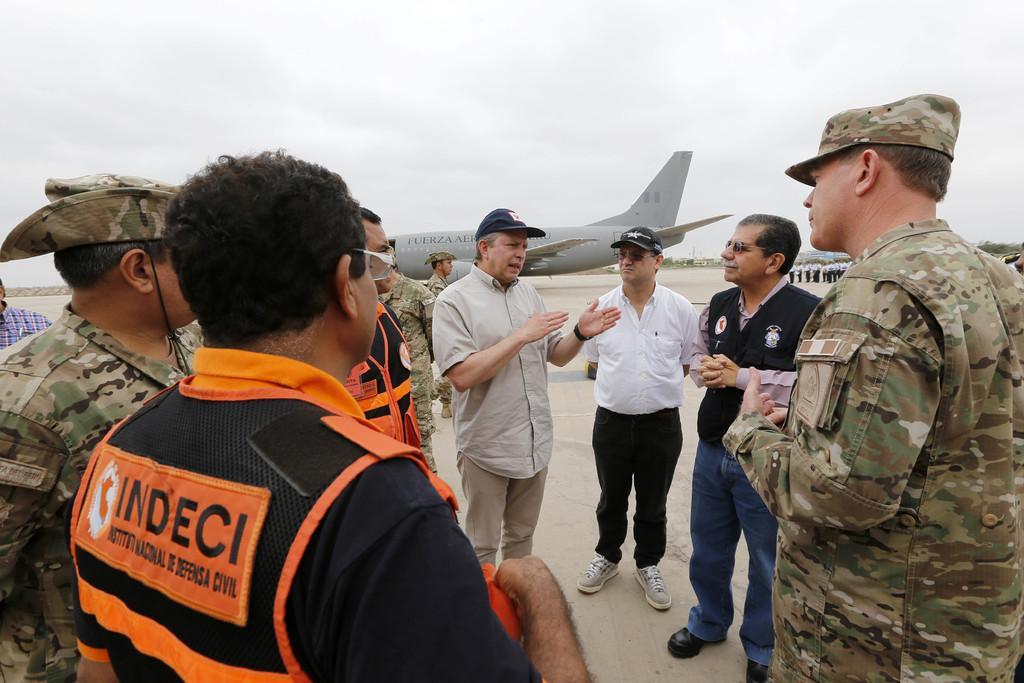Describe this image in one or two sentences. In this image we can see group of persons standing on the ground some persons are wearing military uniforms and caps. In the background, we can see an airplane placed on the ground, group of trees and the sky. 